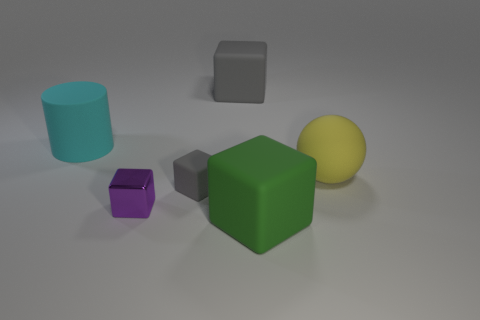What are the different colors of the objects, and how many objects of each color are there? In the image, there are five objects with distinct colors. There's one green cube, one cyan cylinder, one yellow sphere, one purple cube, and two gray cubes of different sizes.  Could you describe the sizes of these objects relative to each other? Certainly! In the image, the green cube is the largest object, followed by the yellow sphere, which is slightly smaller. The cyan cylinder is medium-sized, comparable to the smaller gray cube. The purple cube is the smallest object, and the larger gray cube is slightly bigger than the cyan cylinder but smaller than the yellow sphere. 